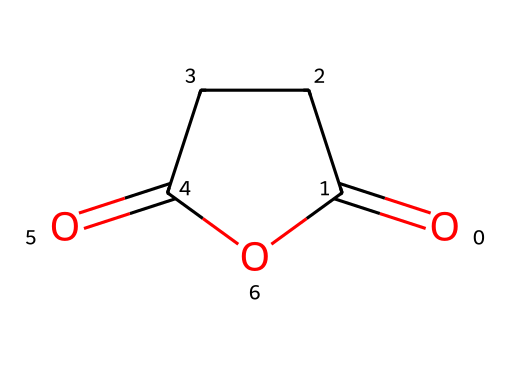What is the name of this chemical? The SMILES representation indicates that the structure corresponds to a cyclic anhydride formed from succinic acid. Therefore, its common name is succinic anhydride.
Answer: succinic anhydride How many carbon atoms are in succinic anhydride? Analyzing the chemical structure, there are four carbon atoms visible, making up the main ring and the carbonyl groups.
Answer: four What is the primary functional group present in succinic anhydride? In the structure provided, the principal functional group is the anhydride, characterized by the presence of two carbonyl groups (C=O) adjacent to an ether link (the oxygen atom connected to the two carbonyl carbons).
Answer: anhydride How many double bonds are in succinic anhydride? Examining the structure, we see that there are two carbonyl groups, each contributing one double bond to the total count, leading to a total of two double bonds present.
Answer: two What property of succinic anhydride makes it useful in pharmaceuticals? The anhydride functional group allows succinic anhydride to react with nucleophiles, which is an important property in the synthesis of pharmaceutical compounds, facilitating various chemical reactions needed for drug development.
Answer: reactivity Is succinic anhydride soluble in water? Based on the structure and the presence of polar functional groups, it can interact with water due to hydrogen bonding, which generally indicates moderate solubility in water for similar compounds.
Answer: yes What type of reaction is commonly associated with succinic anhydride? Succinic anhydride is known to undergo hydrolysis in the presence of water, leading to the formation of succinic acid, which is a typical reaction for anhydrides involving nucleophilic attack.
Answer: hydrolysis 